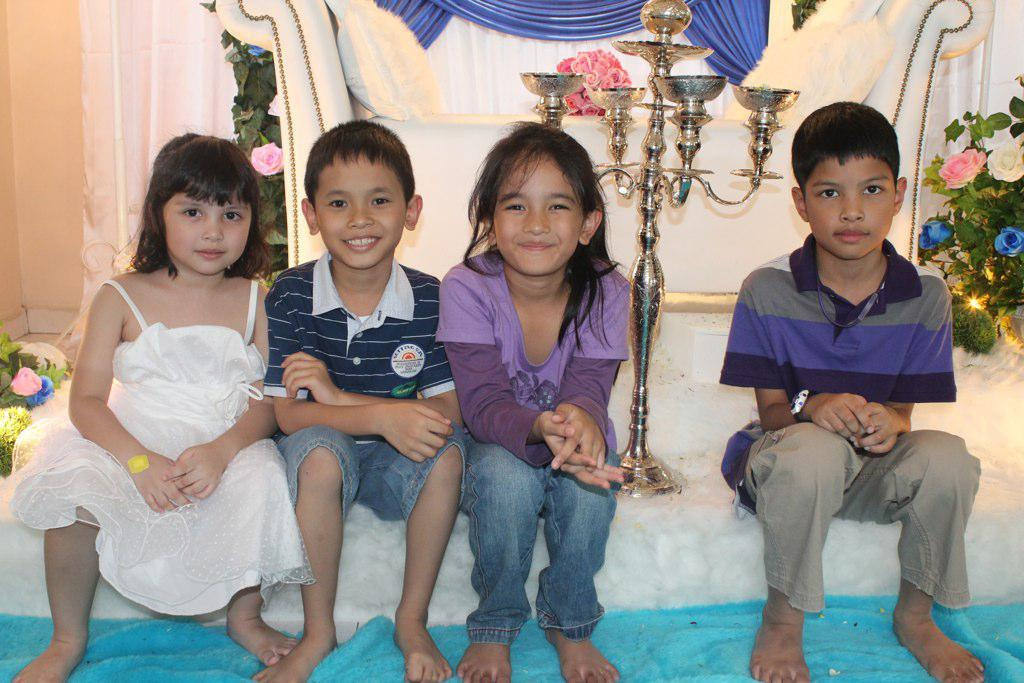How many children are present in the image? There are four children sitting in the image. What is the facial expression of the children? The children are smiling. What are the children wearing? The children are wearing clothes. What type of furniture is in the image? There is a sofa in the image. What is the color of the sofa? The sofa is white in color. What type of plant is in the image? There is a flower plant in the image. What type of lighting fixture is in the image? There is a god lamp in the image. What type of brass scent can be detected in the image? There is no mention of brass or any scent in the image, so it cannot be determined from the image. 